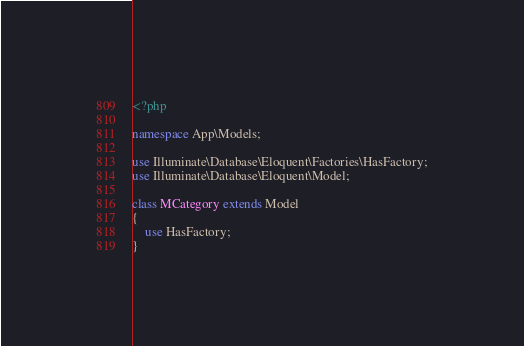Convert code to text. <code><loc_0><loc_0><loc_500><loc_500><_PHP_><?php

namespace App\Models;

use Illuminate\Database\Eloquent\Factories\HasFactory;
use Illuminate\Database\Eloquent\Model;

class MCategory extends Model
{
    use HasFactory;
}
</code> 